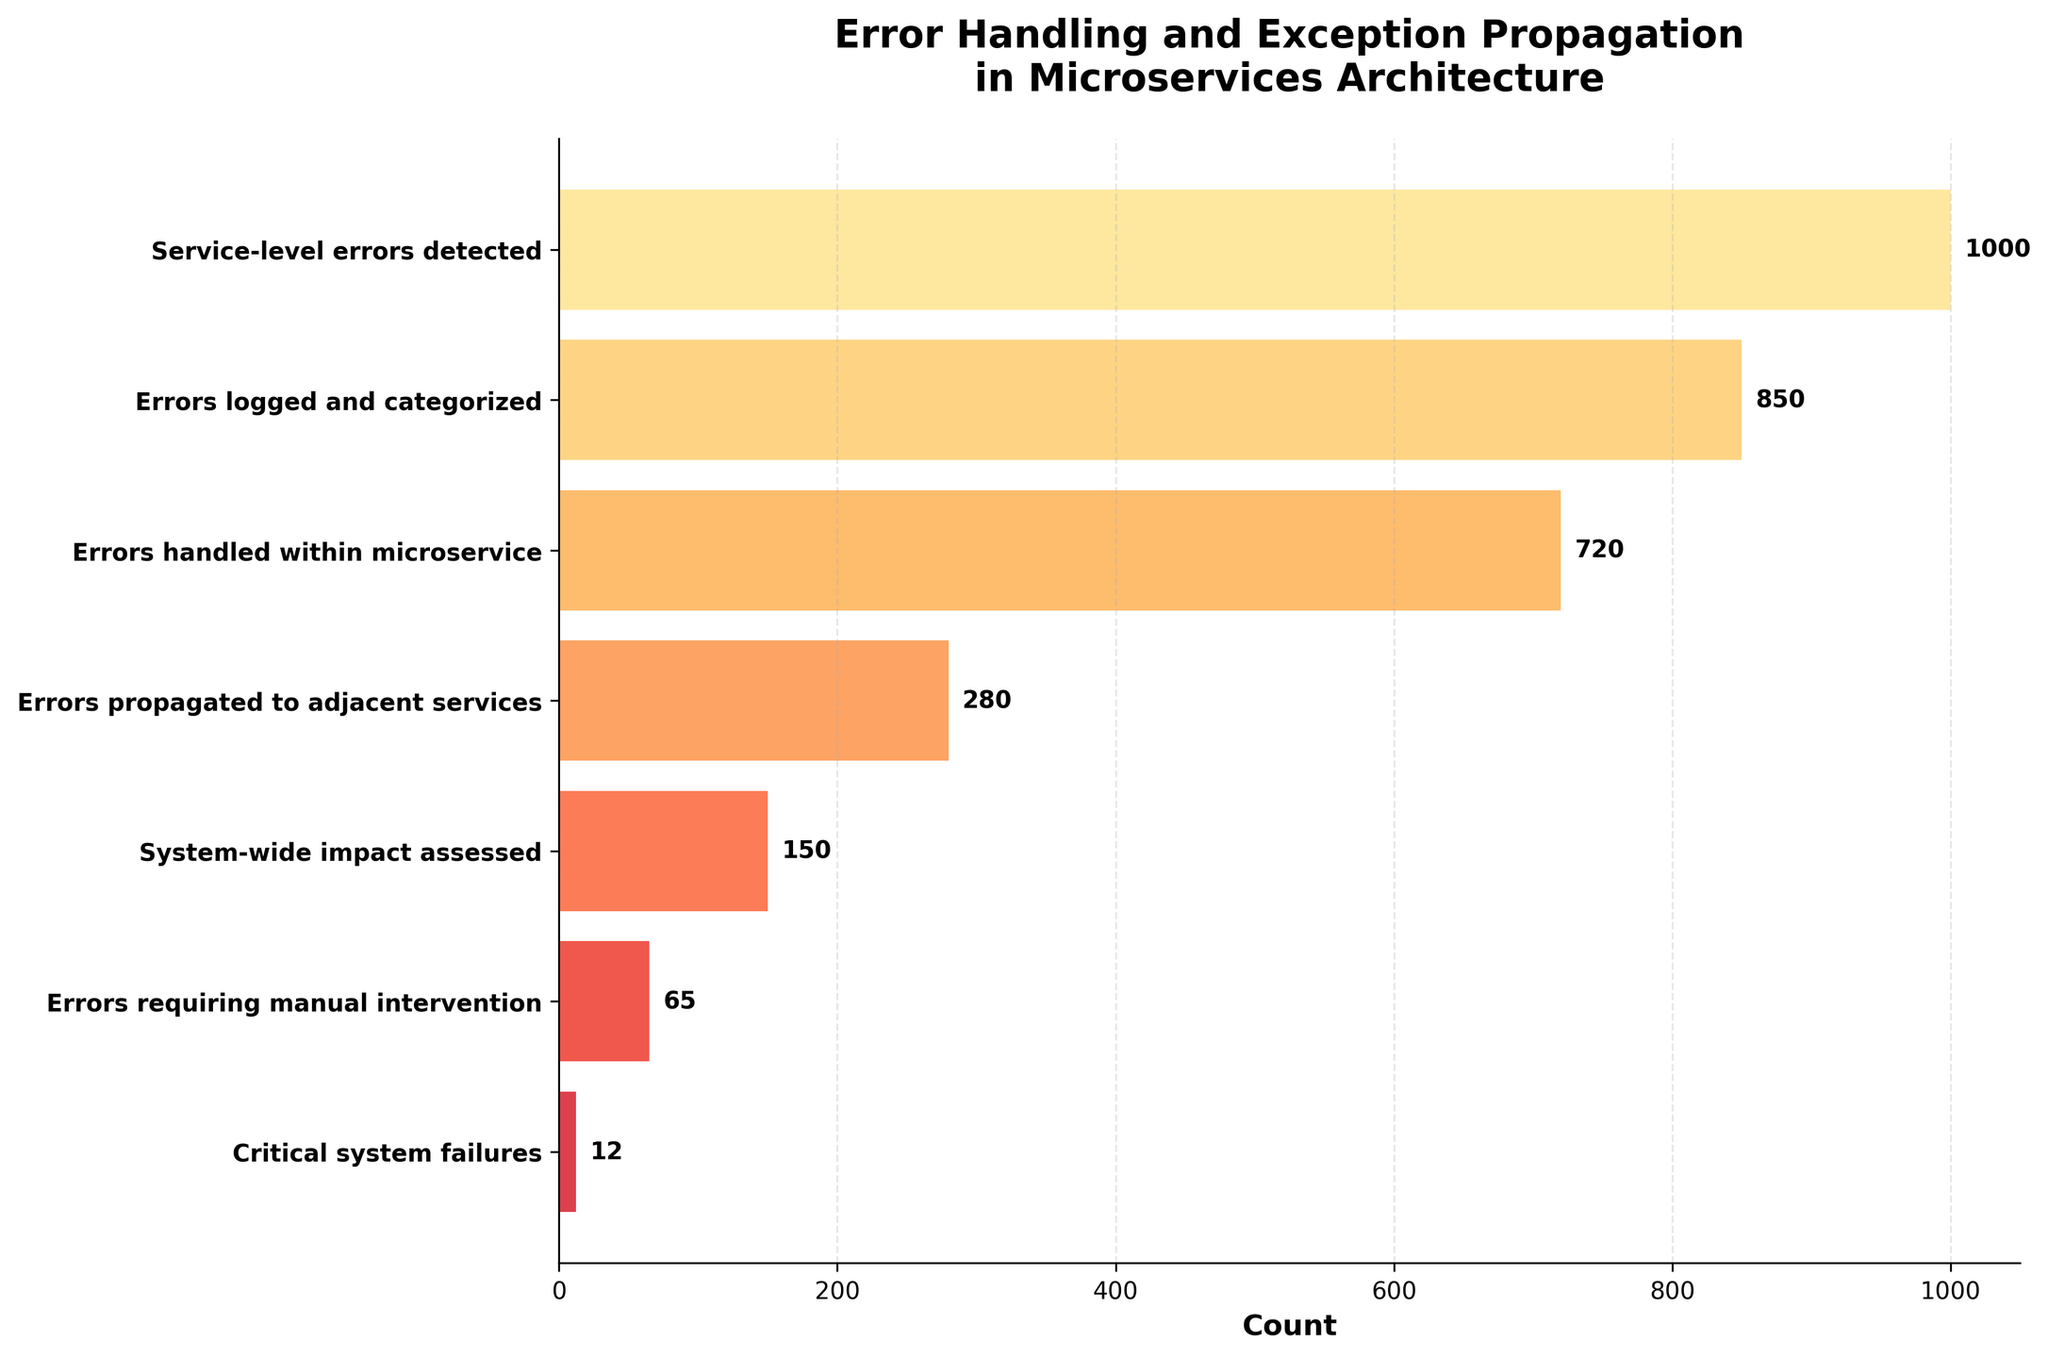What is the title of the funnel chart? The title of the funnel chart is located at the top center of the figure and reads "Error Handling and Exception Propagation in Microservices Architecture."
Answer: Error Handling and Exception Propagation in Microservices Architecture How many errors were detected at the service level? The data point for "Service-level errors detected" is at the very top of the funnel chart, showing the count value.
Answer: 1000 What stage immediately follows "Errors handled within microservice"? The stages are listed vertically in descending order. The stage immediately following "Errors handled within microservice" is "Errors propagated to adjacent services."
Answer: Errors propagated to adjacent services What is the total number of errors that propagated to other stages after being detected at the service-level? The propagation stages can be read sequentially: Errors logged and categorized, Errors handled within microservice, Errors propagated to adjacent services, System-wide impact assessed, Errors requiring manual intervention, and Critical system failures. Summing their counts: 850 + 720 + 280 + 150 + 65 + 12 = 2077. However, this seems higher than starting count due to multiple stages. An accurate count on initial stage handling is needed by noting key values.
Answer: 720 What is the ratio of errors requiring manual intervention to the total system-wide impacts assessed? The number of errors requiring manual intervention is 65 and the number of system-wide impacts assessed is 150. Calculating the ratio: 65 / 150 = 0.433 (or approximately 43.3%).
Answer: 0.433 or 43.3% Which stage has the largest drop in error count from the previous stage? By observing the counts sequentially and calculating absolute differences: 
- Errors logged and categorized from Service-level errors detected: 1000 - 850 = 150
- Errors handled within microservice from Errors logged: 850 - 720 = 130
- Errors propagated to adjacent services from Errors handled: 720 - 280 = 440
- System-wide impact assessed from Errors propagated: 280 - 150 = 130
- Errors requiring manual intervention from System-wide impact assessed: 150 - 65 = 85
- Critical system failures from Errors requiring manual intervention: 65 - 12 = 53
The largest drop is between "Errors handled within microservice" to "Errors propagated to adjacent services."
Answer: Errors propagated to adjacent services How many stages are there in the funnel chart? Each stage in the funnel chart corresponds to a unique data point forming the funnel. Counting the listed stages from top to bottom results in seven stages.
Answer: 7 What percentage of the detected service-level errors result in critical system failures? First, note the counts for the stages in question. Service-level errors detected: 1000; Critical system failures: 12. Calculating the percentage: (12 / 1000) * 100 = 1.2%.
Answer: 1.2% What color scheme is used in the funnel chart? The funnel chart uses a gradient color scheme ranging from light yellow to darker red, as indicated by the YlOrRd colormap provided.
Answer: Gradient from light yellow to dark red Is the number of errors handled within microservice more, less, or the same compared to the errors logged and categorized? Compare the counts of the respectively mentioned stages: Errors handled within microservice (720) and Errors logged and categorized (850). Logically, 720 is less than 850.
Answer: Less 